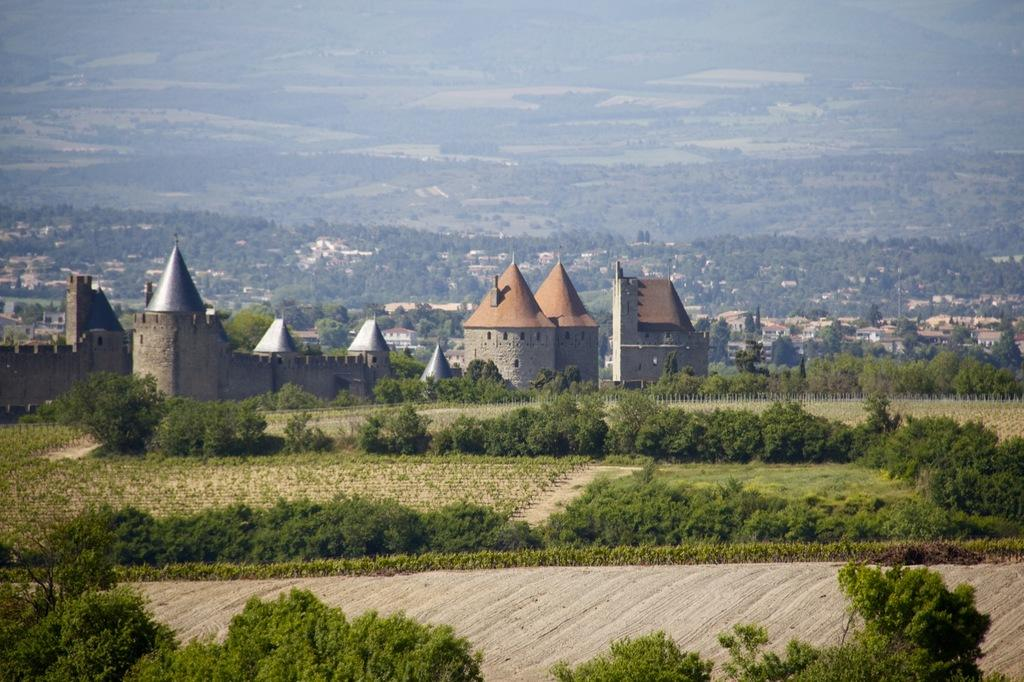What type of vegetation can be seen in the image? There are trees in the image. What can be seen in the background of the image? There is a wall and a roof top visible in the background of the image. Are there any other trees visible in the background? Yes, there are additional trees in the background of the image. What type of honey can be seen dripping from the trees in the image? There is no honey present in the image; it features trees and a background with a wall and roof top. 